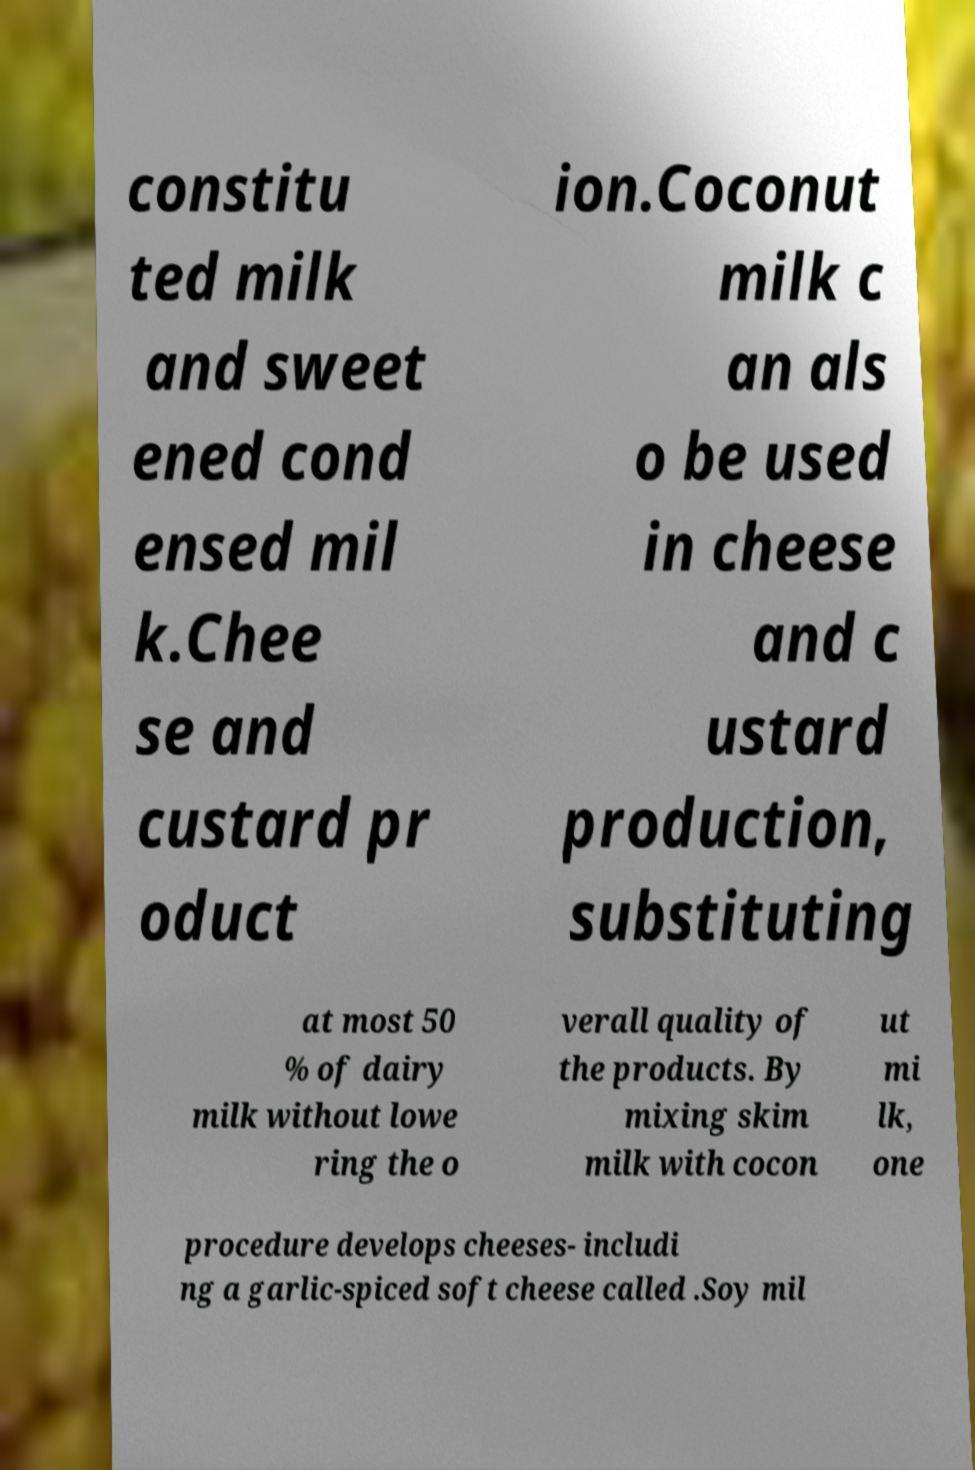For documentation purposes, I need the text within this image transcribed. Could you provide that? constitu ted milk and sweet ened cond ensed mil k.Chee se and custard pr oduct ion.Coconut milk c an als o be used in cheese and c ustard production, substituting at most 50 % of dairy milk without lowe ring the o verall quality of the products. By mixing skim milk with cocon ut mi lk, one procedure develops cheeses- includi ng a garlic-spiced soft cheese called .Soy mil 